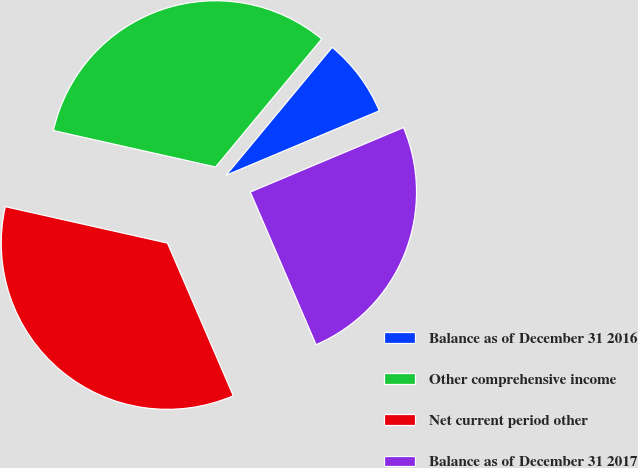Convert chart to OTSL. <chart><loc_0><loc_0><loc_500><loc_500><pie_chart><fcel>Balance as of December 31 2016<fcel>Other comprehensive income<fcel>Net current period other<fcel>Balance as of December 31 2017<nl><fcel>7.64%<fcel>32.5%<fcel>34.99%<fcel>24.86%<nl></chart> 